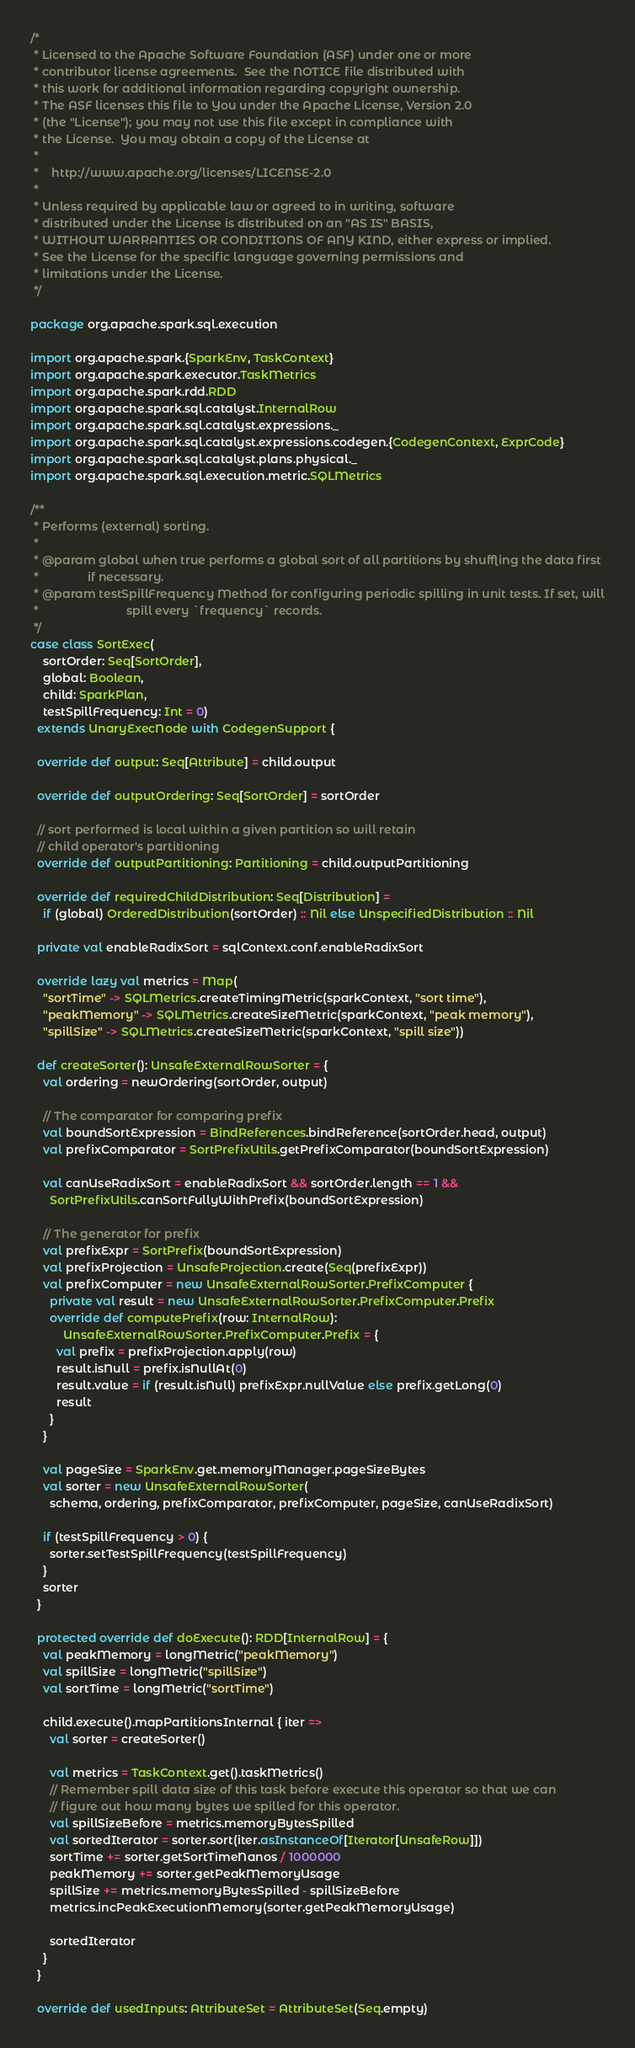<code> <loc_0><loc_0><loc_500><loc_500><_Scala_>/*
 * Licensed to the Apache Software Foundation (ASF) under one or more
 * contributor license agreements.  See the NOTICE file distributed with
 * this work for additional information regarding copyright ownership.
 * The ASF licenses this file to You under the Apache License, Version 2.0
 * (the "License"); you may not use this file except in compliance with
 * the License.  You may obtain a copy of the License at
 *
 *    http://www.apache.org/licenses/LICENSE-2.0
 *
 * Unless required by applicable law or agreed to in writing, software
 * distributed under the License is distributed on an "AS IS" BASIS,
 * WITHOUT WARRANTIES OR CONDITIONS OF ANY KIND, either express or implied.
 * See the License for the specific language governing permissions and
 * limitations under the License.
 */

package org.apache.spark.sql.execution

import org.apache.spark.{SparkEnv, TaskContext}
import org.apache.spark.executor.TaskMetrics
import org.apache.spark.rdd.RDD
import org.apache.spark.sql.catalyst.InternalRow
import org.apache.spark.sql.catalyst.expressions._
import org.apache.spark.sql.catalyst.expressions.codegen.{CodegenContext, ExprCode}
import org.apache.spark.sql.catalyst.plans.physical._
import org.apache.spark.sql.execution.metric.SQLMetrics

/**
 * Performs (external) sorting.
 *
 * @param global when true performs a global sort of all partitions by shuffling the data first
 *               if necessary.
 * @param testSpillFrequency Method for configuring periodic spilling in unit tests. If set, will
 *                           spill every `frequency` records.
 */
case class SortExec(
    sortOrder: Seq[SortOrder],
    global: Boolean,
    child: SparkPlan,
    testSpillFrequency: Int = 0)
  extends UnaryExecNode with CodegenSupport {

  override def output: Seq[Attribute] = child.output

  override def outputOrdering: Seq[SortOrder] = sortOrder

  // sort performed is local within a given partition so will retain
  // child operator's partitioning
  override def outputPartitioning: Partitioning = child.outputPartitioning

  override def requiredChildDistribution: Seq[Distribution] =
    if (global) OrderedDistribution(sortOrder) :: Nil else UnspecifiedDistribution :: Nil

  private val enableRadixSort = sqlContext.conf.enableRadixSort

  override lazy val metrics = Map(
    "sortTime" -> SQLMetrics.createTimingMetric(sparkContext, "sort time"),
    "peakMemory" -> SQLMetrics.createSizeMetric(sparkContext, "peak memory"),
    "spillSize" -> SQLMetrics.createSizeMetric(sparkContext, "spill size"))

  def createSorter(): UnsafeExternalRowSorter = {
    val ordering = newOrdering(sortOrder, output)

    // The comparator for comparing prefix
    val boundSortExpression = BindReferences.bindReference(sortOrder.head, output)
    val prefixComparator = SortPrefixUtils.getPrefixComparator(boundSortExpression)

    val canUseRadixSort = enableRadixSort && sortOrder.length == 1 &&
      SortPrefixUtils.canSortFullyWithPrefix(boundSortExpression)

    // The generator for prefix
    val prefixExpr = SortPrefix(boundSortExpression)
    val prefixProjection = UnsafeProjection.create(Seq(prefixExpr))
    val prefixComputer = new UnsafeExternalRowSorter.PrefixComputer {
      private val result = new UnsafeExternalRowSorter.PrefixComputer.Prefix
      override def computePrefix(row: InternalRow):
          UnsafeExternalRowSorter.PrefixComputer.Prefix = {
        val prefix = prefixProjection.apply(row)
        result.isNull = prefix.isNullAt(0)
        result.value = if (result.isNull) prefixExpr.nullValue else prefix.getLong(0)
        result
      }
    }

    val pageSize = SparkEnv.get.memoryManager.pageSizeBytes
    val sorter = new UnsafeExternalRowSorter(
      schema, ordering, prefixComparator, prefixComputer, pageSize, canUseRadixSort)

    if (testSpillFrequency > 0) {
      sorter.setTestSpillFrequency(testSpillFrequency)
    }
    sorter
  }

  protected override def doExecute(): RDD[InternalRow] = {
    val peakMemory = longMetric("peakMemory")
    val spillSize = longMetric("spillSize")
    val sortTime = longMetric("sortTime")

    child.execute().mapPartitionsInternal { iter =>
      val sorter = createSorter()

      val metrics = TaskContext.get().taskMetrics()
      // Remember spill data size of this task before execute this operator so that we can
      // figure out how many bytes we spilled for this operator.
      val spillSizeBefore = metrics.memoryBytesSpilled
      val sortedIterator = sorter.sort(iter.asInstanceOf[Iterator[UnsafeRow]])
      sortTime += sorter.getSortTimeNanos / 1000000
      peakMemory += sorter.getPeakMemoryUsage
      spillSize += metrics.memoryBytesSpilled - spillSizeBefore
      metrics.incPeakExecutionMemory(sorter.getPeakMemoryUsage)

      sortedIterator
    }
  }

  override def usedInputs: AttributeSet = AttributeSet(Seq.empty)
</code> 